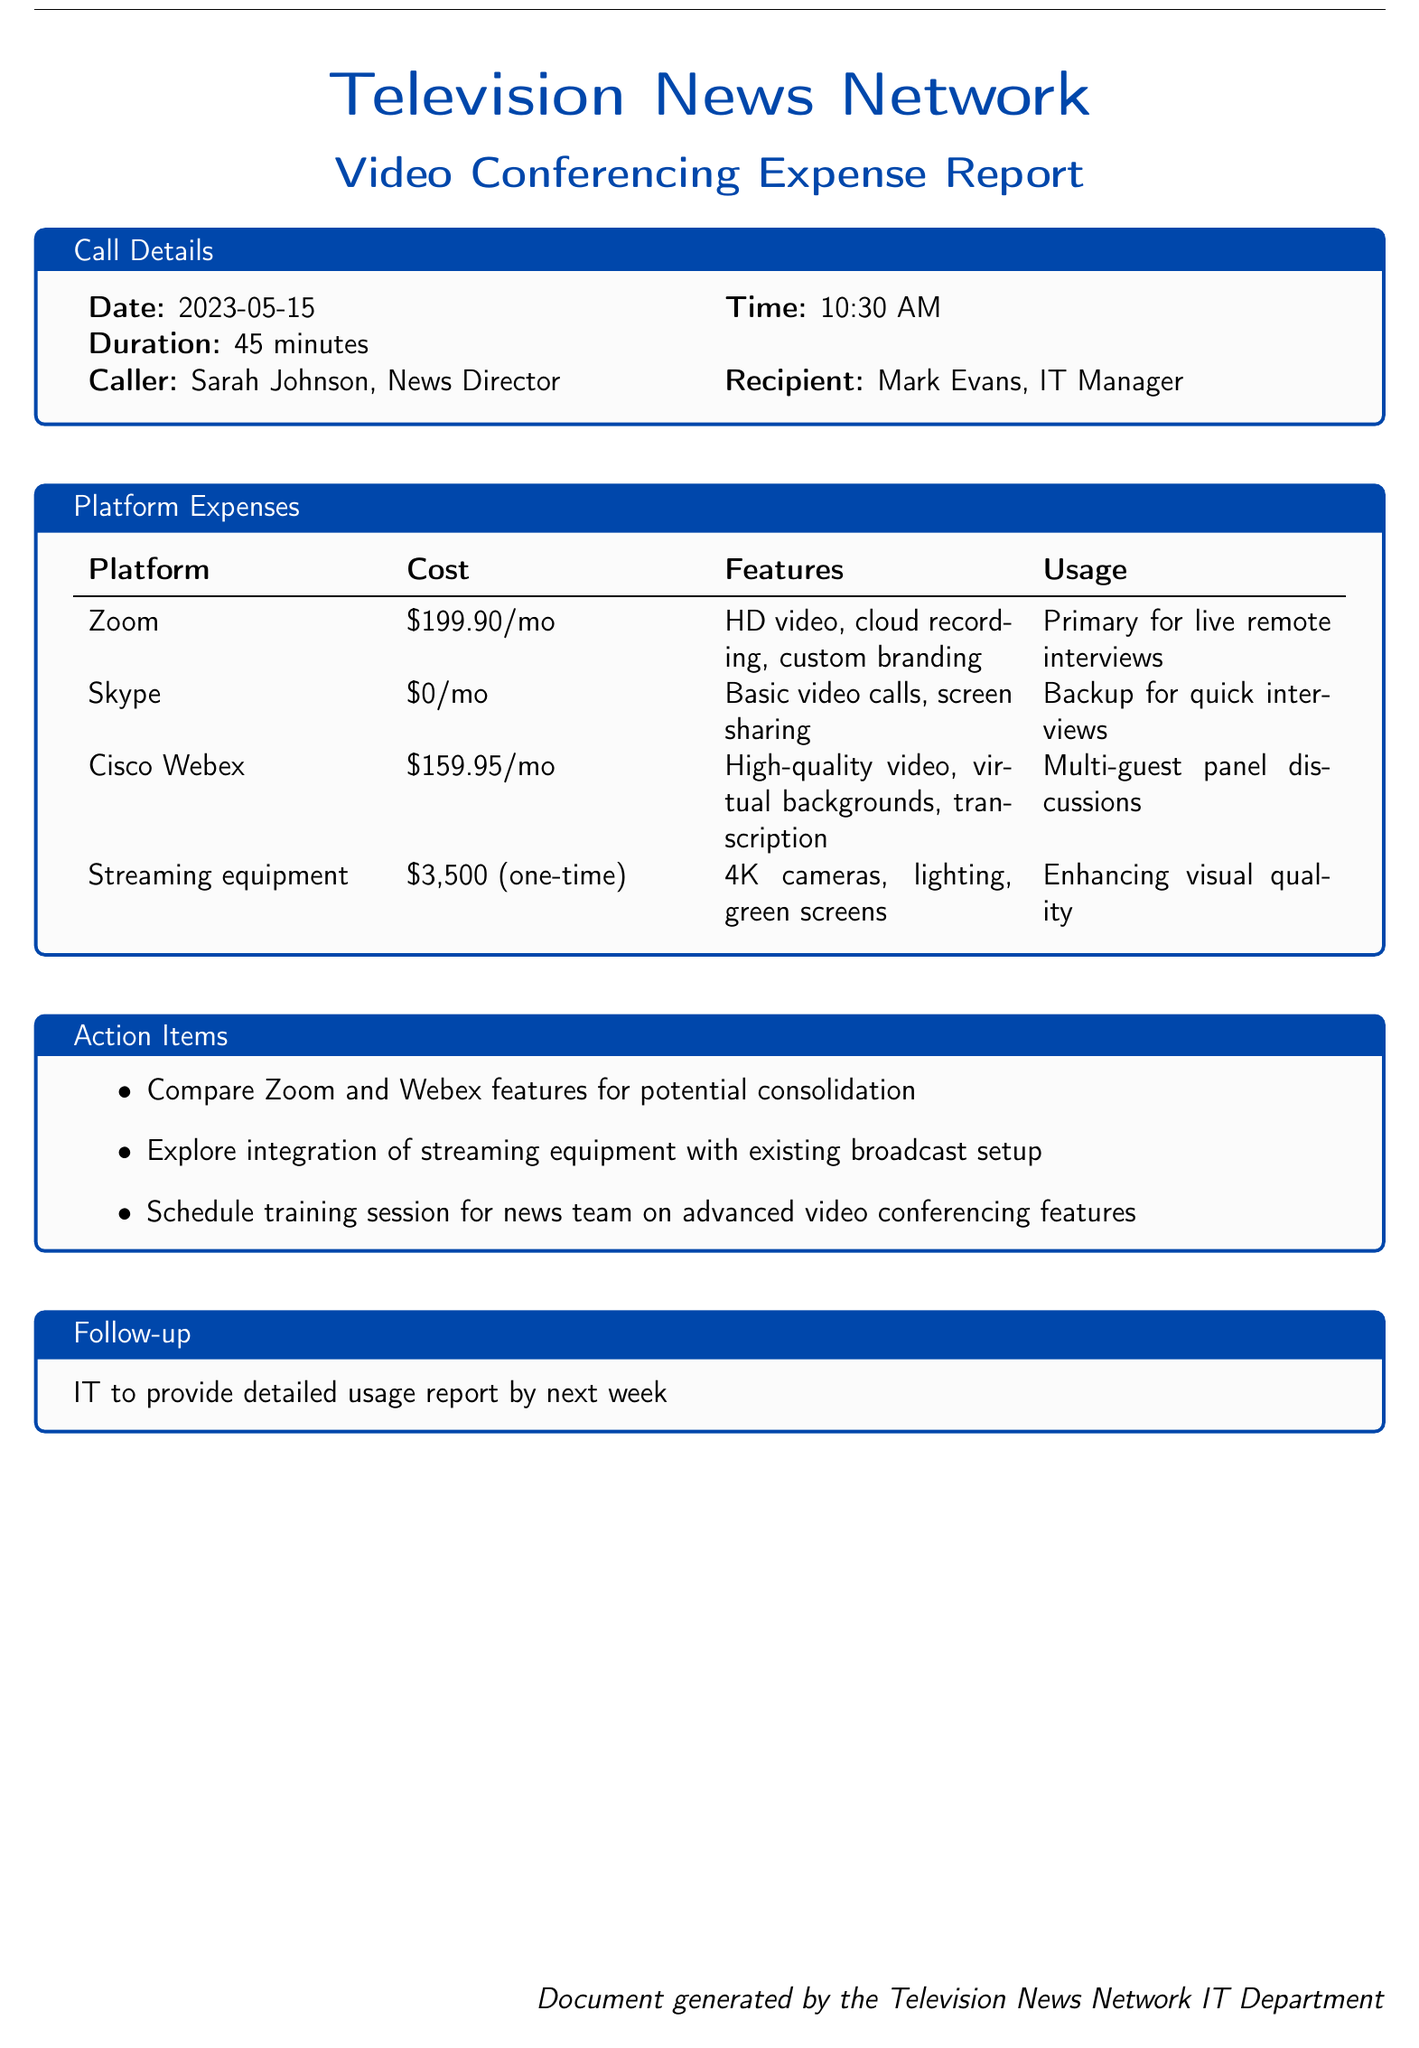What is the date of the call? The document specifies the date of the call details section.
Answer: 2023-05-15 Who is the caller identified in the document? The caller is mentioned in the "Call Details" section.
Answer: Sarah Johnson, News Director What is the cost of the Zoom subscription? The cost for the Zoom platform is listed in the "Platform Expenses" section.
Answer: $199.90/mo What is the one-time cost for the streaming equipment? The "Platform Expenses" section includes the one-time cost for streaming equipment.
Answer: $3,500 Which platform is used as a backup for quick interviews? The "Platform Expenses" identifies the specified platform for quick interviews.
Answer: Skype How long was the duration of the call? The duration of the call is provided in the "Call Details" section.
Answer: 45 minutes What feature is unique to Cisco Webex? The features listed for Cisco Webex in "Platform Expenses" highlight a unique aspect.
Answer: Virtual backgrounds What is the action item related to Zoom and Webex? One of the action items suggests an investigation regarding Zoom and Webex.
Answer: Compare Zoom and Webex features for potential consolidation When is IT supposed to provide a detailed usage report? The follow-up section indicates when the report is expected.
Answer: Next week 